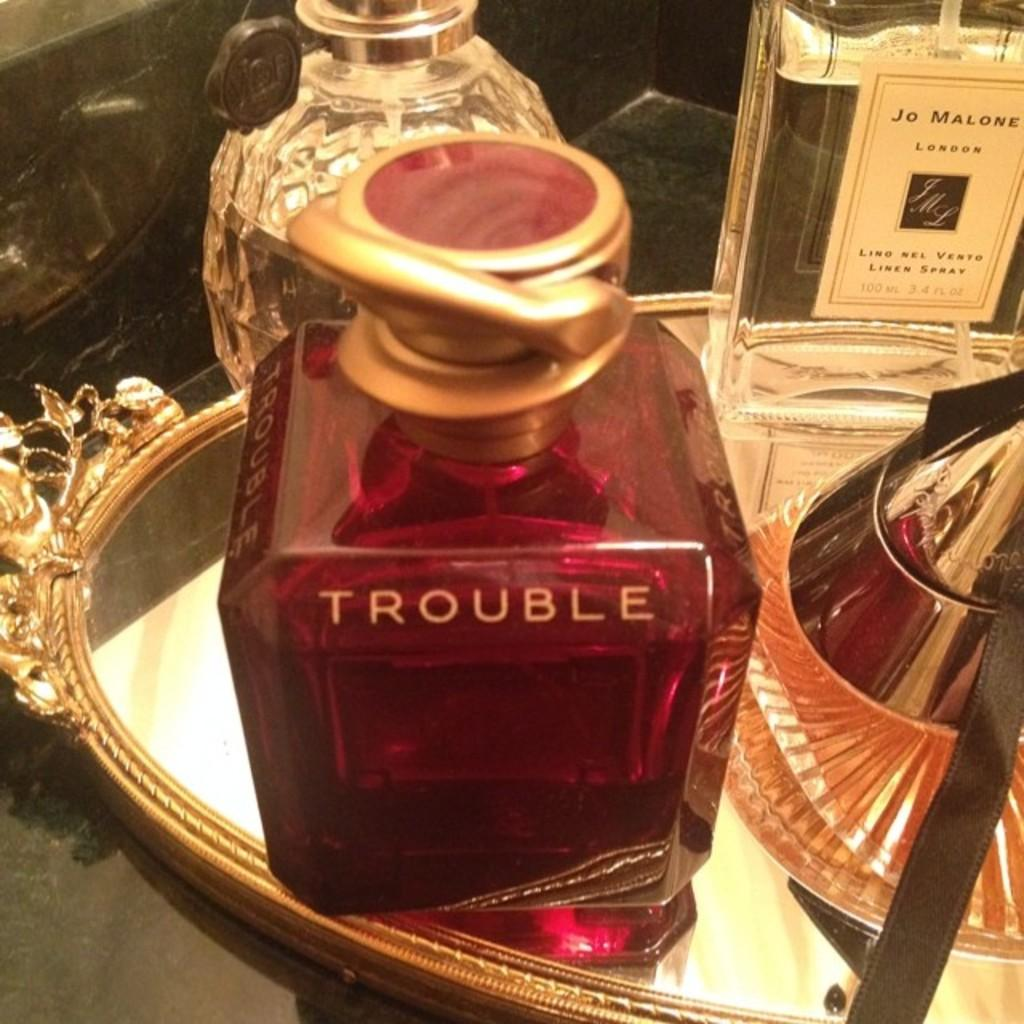Provide a one-sentence caption for the provided image. A bottle of perfume with the word Trouble written on it. 